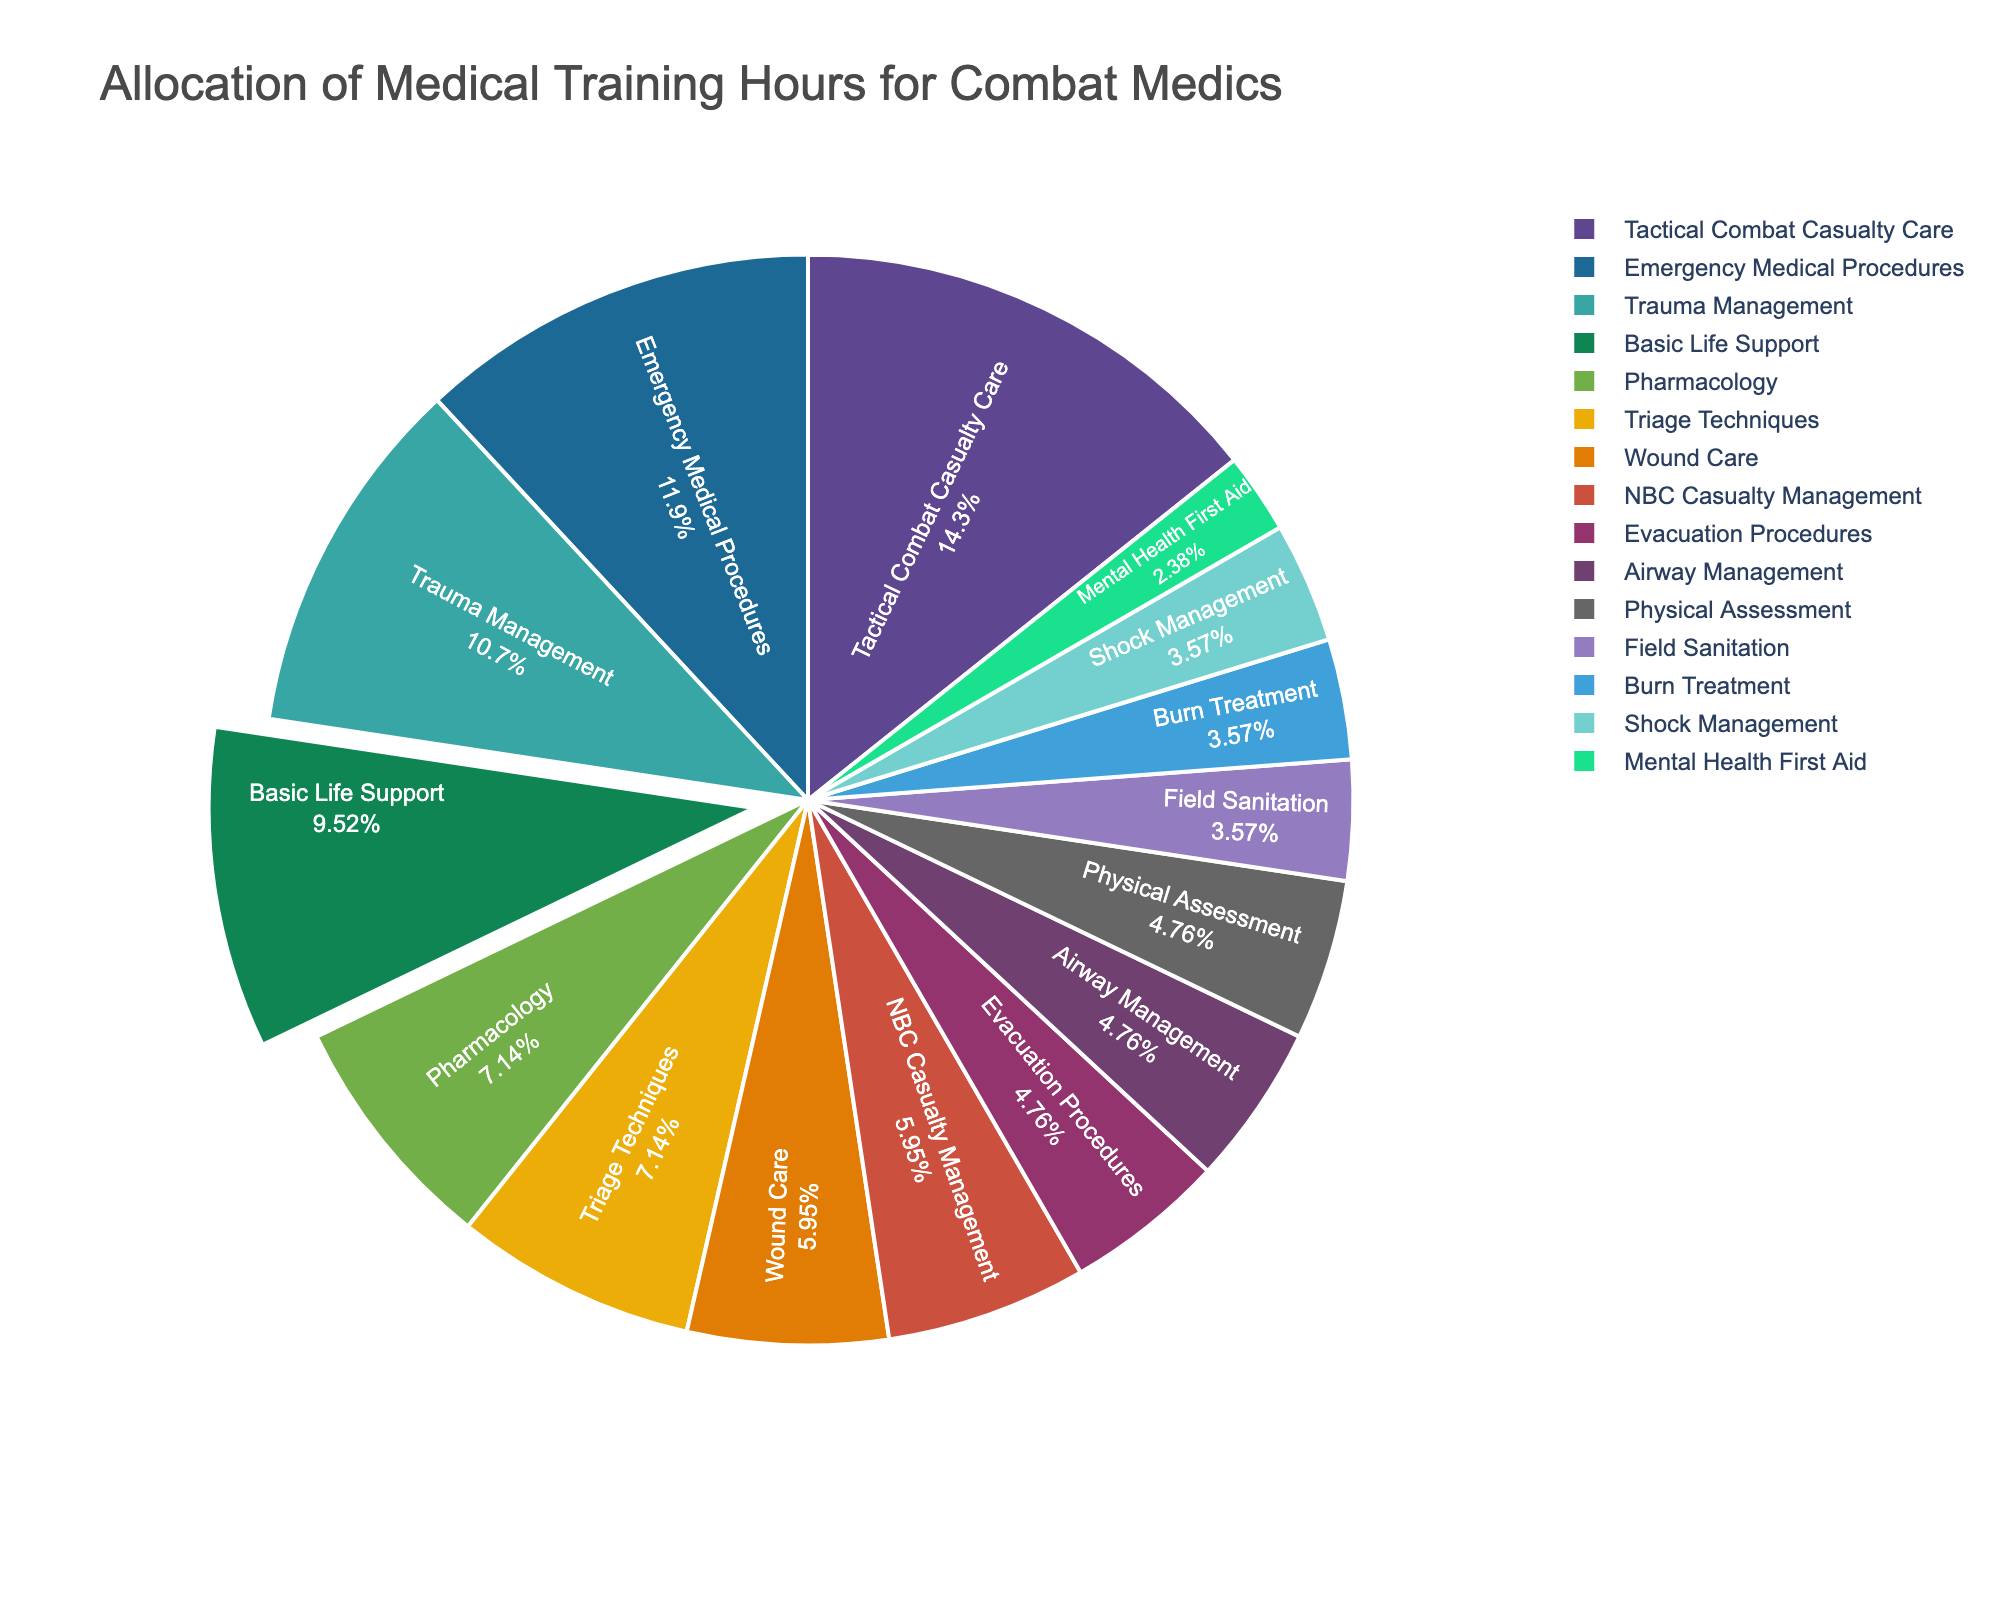How many total hours are dedicated to basic life support, tactical combat casualty care, and emergency medical procedures? Sum the hours allocated for Basic Life Support (40), Tactical Combat Casualty Care (60), and Emergency Medical Procedures (50): 40 + 60 + 50 = 150
Answer: 150 Which training topic has the highest allocation of hours, and how many hours are allocated? To determine the highest allocation, compare the hours for each training topic. Tactical Combat Casualty Care has 60 hours, which is the highest.
Answer: Tactical Combat Casualty Care, 60 What percentage of the total training hours is spent on trauma management and wound care combined? First, find the total hours allocated: 40 + 60 + 30 + 15 + 50 + 45 + 25 + 20 + 15 + 10 + 25 + 15 + 20 + 30 + 20 = 420 hours. Next, sum the hours for Trauma Management (45) and Wound Care (25): 45 + 25 = 70. Finally, calculate the percentage: (70/420) * 100 ≈ 16.67%
Answer: 16.67% How does the allocation of hours for NBC Casualty Management compare to Physical Assessment? Compare the hours allocated for each: NBC Casualty Management has 25 hours, and Physical Assessment has 20 hours. NBC Casualty Management has 5 more hours than Physical Assessment.
Answer: NBC Casualty Management has 5 more hours Which training topic has the least allocation of hours, and how many hours are allocated? Compare the hours for each training topic to identify the smallest value. Mental Health First Aid has the fewest hours with 10.
Answer: Mental Health First Aid, 10 What is the difference between the total hours allocated to airway management and evacuation procedures? Subtract the hours for Evacuation Procedures (20) from Airway Management (20): 20 - 20 = 0
Answer: 0 What's the total percentage of training hours dedicated to field sanitation and shock management? Sum the hours for Field Sanitation (15) and Shock Management (15): 15 + 15 = 30. Divide by the total hours (420) and convert to percentage: (30/420) * 100 ≈ 7.14%
Answer: 7.14% If the hours for pharmacology are doubled, what would be its new percentage of the total training hours? Double the hours for Pharmacology: 30 * 2 = 60. Add this increased allocation to the original total: 420 + 30 = 450 hours. Calculate the new percentage: (60/450) * 100 ≈ 13.33%
Answer: 13.33% Among the topics listed, which one has hours allocation closest to the average hours per topic? Calculate the average hours: total hours (420) divided by the number of topics (15): 420/15 = 28. The closest allocation to 28 hours is Wound Care with 25 hours.
Answer: Wound Care, 25 What is the combined allocation of hours for NBC casualty management, burn treatment, and mental health first aid? Sum the hours for NBC Casualty Management (25), Burn Treatment (15), and Mental Health First Aid (10): 25 + 15 + 10 = 50
Answer: 50 